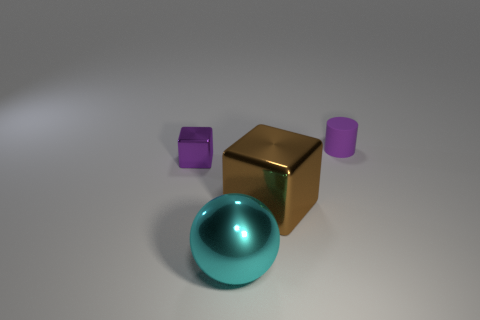How many other objects are the same material as the tiny purple block? Including the tiny purple block, there are two objects that appear to be made from a similar matte material. The second object sharing this characteristic is the taller purple cylinder. 